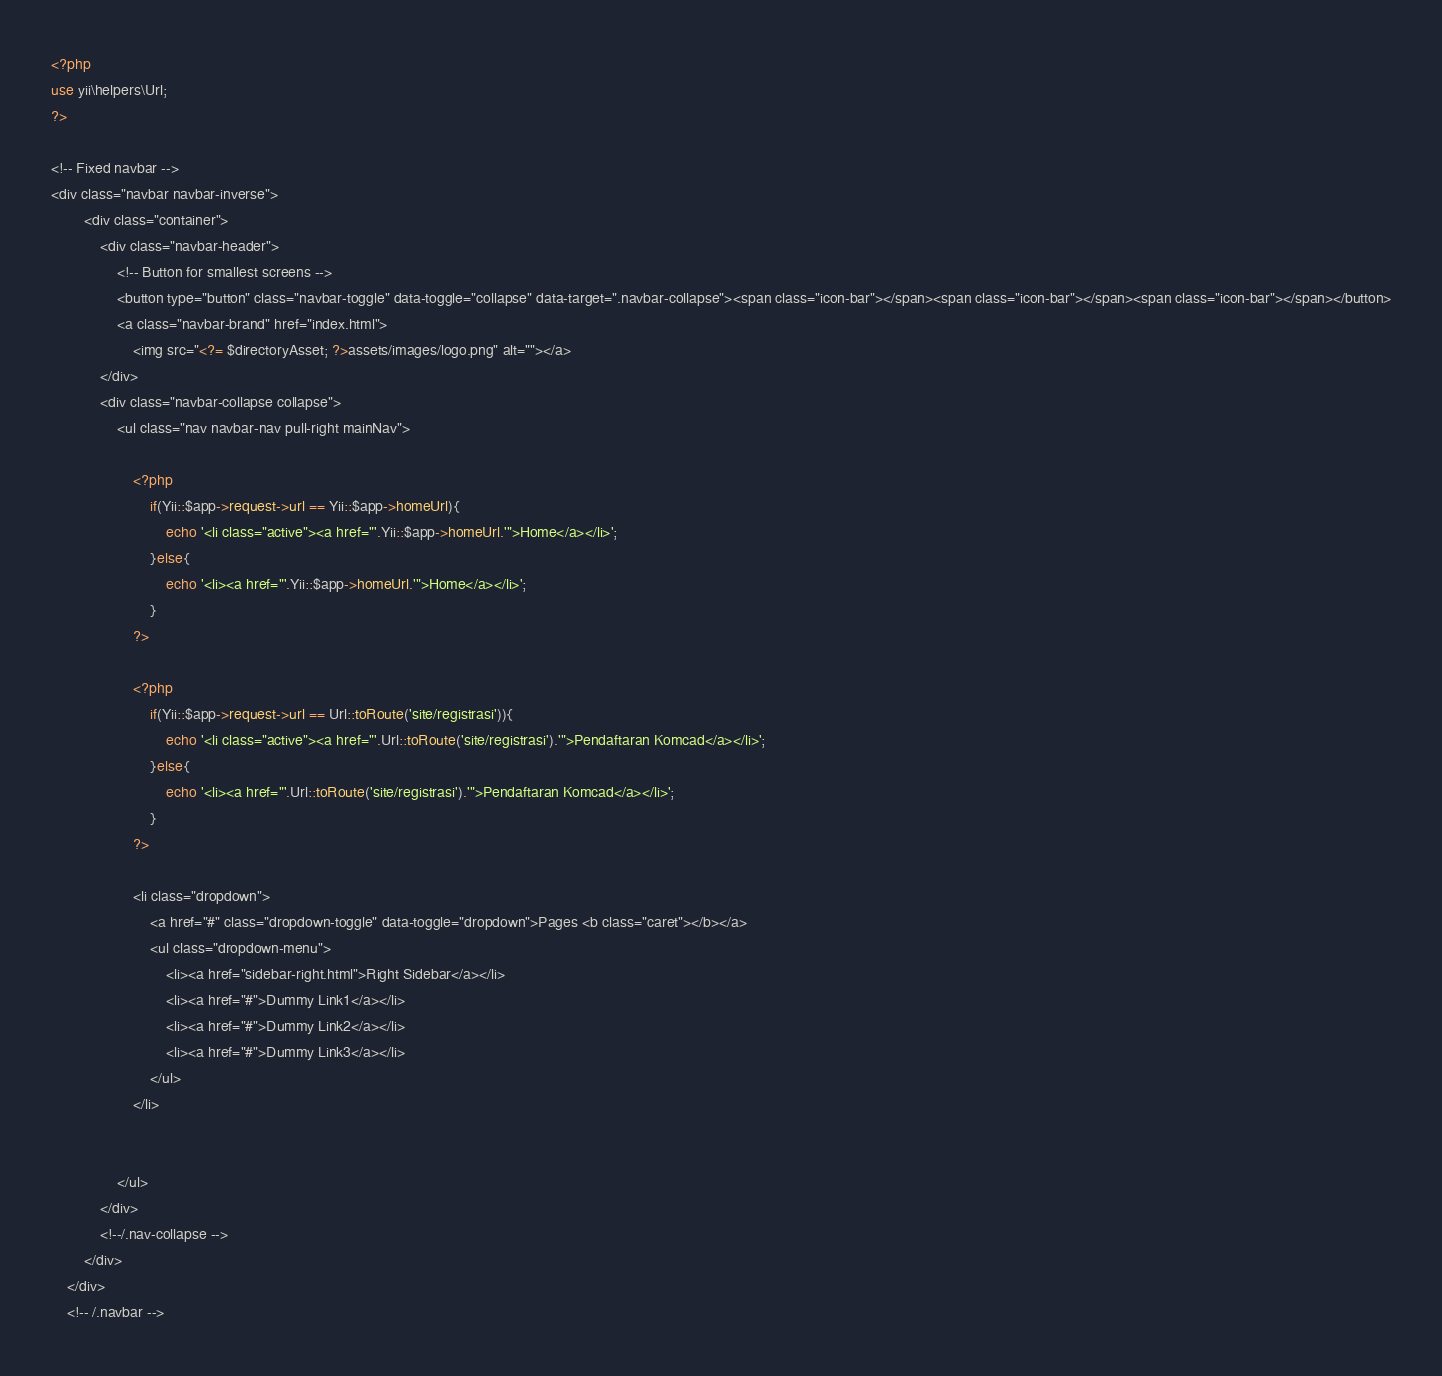<code> <loc_0><loc_0><loc_500><loc_500><_PHP_><?php
use yii\helpers\Url;
?>

<!-- Fixed navbar -->
<div class="navbar navbar-inverse">
		<div class="container">
			<div class="navbar-header">
				<!-- Button for smallest screens -->
				<button type="button" class="navbar-toggle" data-toggle="collapse" data-target=".navbar-collapse"><span class="icon-bar"></span><span class="icon-bar"></span><span class="icon-bar"></span></button>
				<a class="navbar-brand" href="index.html">
					<img src="<?= $directoryAsset; ?>assets/images/logo.png" alt=""></a>
			</div>
			<div class="navbar-collapse collapse">
				<ul class="nav navbar-nav pull-right mainNav">
					
					<?php 
                        if(Yii::$app->request->url == Yii::$app->homeUrl){
                            echo '<li class="active"><a href="'.Yii::$app->homeUrl.'">Home</a></li>';
                        }else{
                            echo '<li><a href="'.Yii::$app->homeUrl.'">Home</a></li>';
                        }
                    ?>

					<?php 
                        if(Yii::$app->request->url == Url::toRoute('site/registrasi')){
                            echo '<li class="active"><a href="'.Url::toRoute('site/registrasi').'">Pendaftaran Komcad</a></li>';
                        }else{
                            echo '<li><a href="'.Url::toRoute('site/registrasi').'">Pendaftaran Komcad</a></li>';
                        }
                    ?>

					<li class="dropdown">
						<a href="#" class="dropdown-toggle" data-toggle="dropdown">Pages <b class="caret"></b></a>
						<ul class="dropdown-menu">
							<li><a href="sidebar-right.html">Right Sidebar</a></li>
							<li><a href="#">Dummy Link1</a></li>
							<li><a href="#">Dummy Link2</a></li>
							<li><a href="#">Dummy Link3</a></li>
						</ul>
					</li>
					

				</ul>
			</div>
			<!--/.nav-collapse -->
		</div>
	</div>
	<!-- /.navbar --></code> 